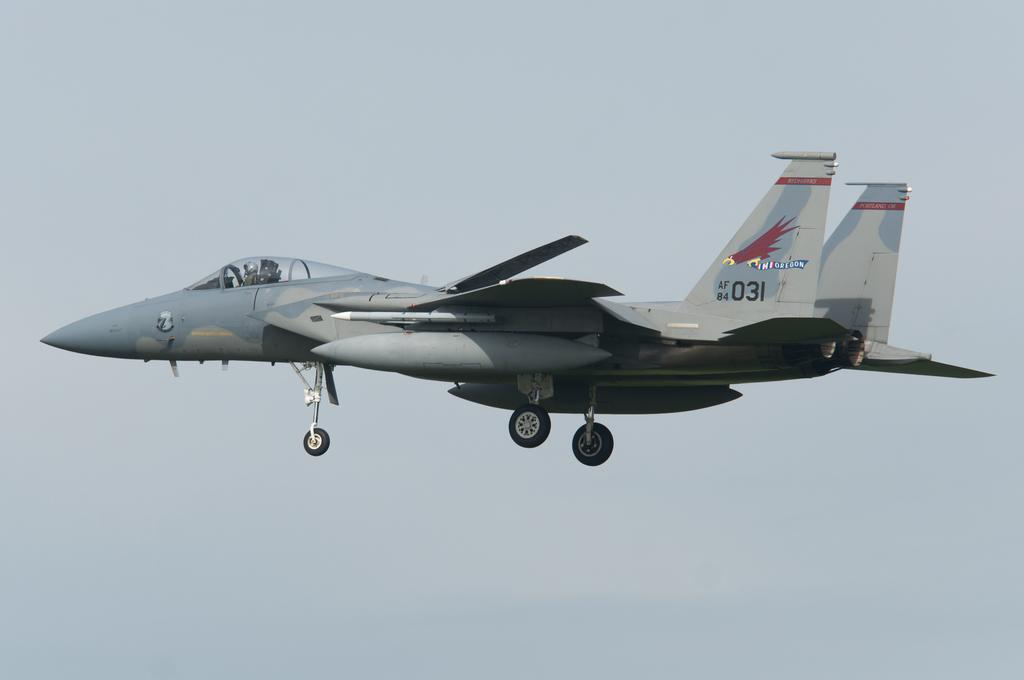<image>
Relay a brief, clear account of the picture shown. A fighter jet that has a bird painted on its wing holding an Oregon banner. 